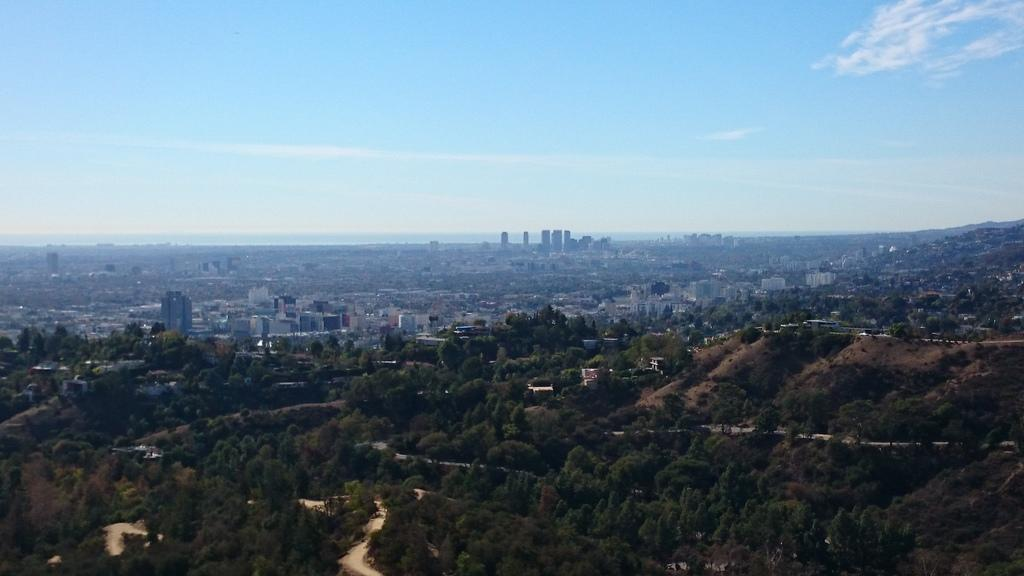What type of view is shown in the image? The image is an aerial view. What natural elements can be seen in the image? There are trees visible in the image. What man-made structures can be seen in the image? There are buildings visible in the image. What is the color of the sky in the image? The sky is blue in color. What can be seen in the background of the image? Clouds are present in the background of the image. What type of amusement can be seen in the image? There is no amusement present in the image; it is an aerial view of trees, buildings, and clouds. What wire-related object can be seen in the image? There is no wire-related object present in the image. 